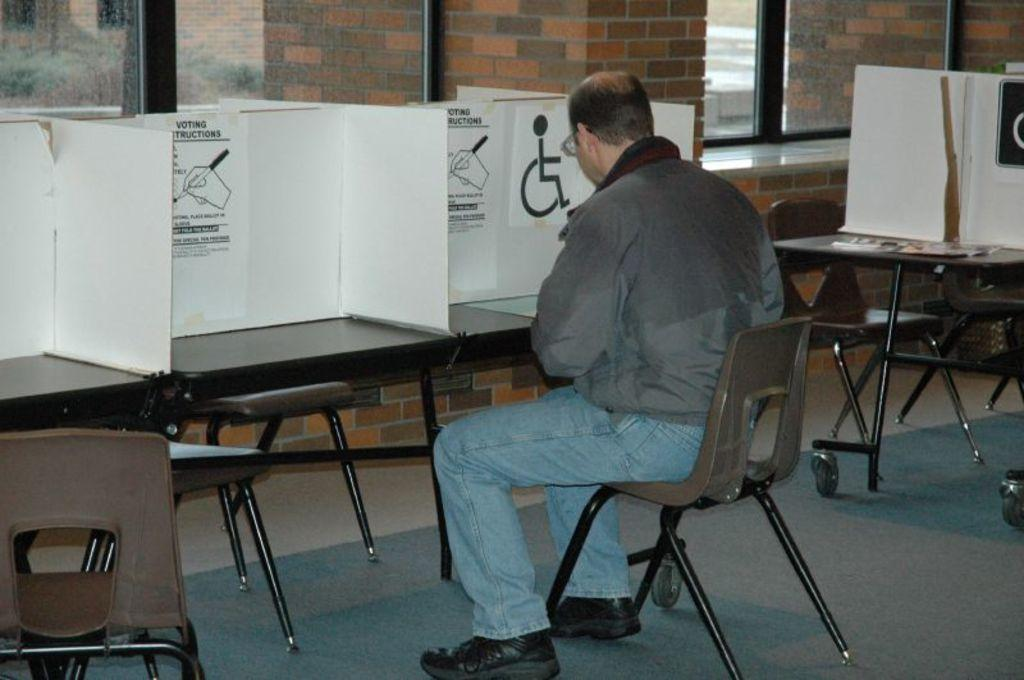What is the man in the image doing? The man is sitting on a chair in the image. What is in front of the chair? There is a table in front of the chair. What can be seen on the table? There are objects on the table. What is the wall made of in the image? The wall in the image is made of bricks. Is there any source of natural light in the image? Yes, there is a window in the image. What type of bomb can be seen on the table in the image? There is no bomb present on the table in the image. 